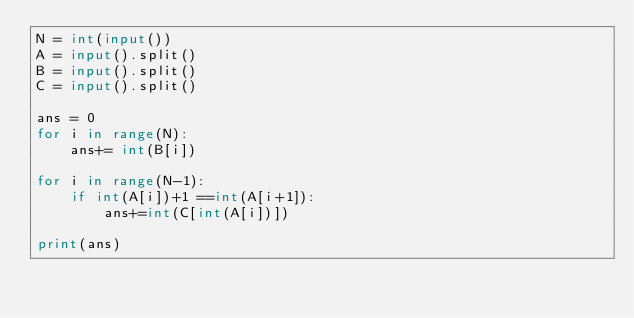Convert code to text. <code><loc_0><loc_0><loc_500><loc_500><_Python_>N = int(input())
A = input().split()
B = input().split()
C = input().split()

ans = 0
for i in range(N):
    ans+= int(B[i])

for i in range(N-1):
    if int(A[i])+1 ==int(A[i+1]):
        ans+=int(C[int(A[i])])

print(ans)</code> 